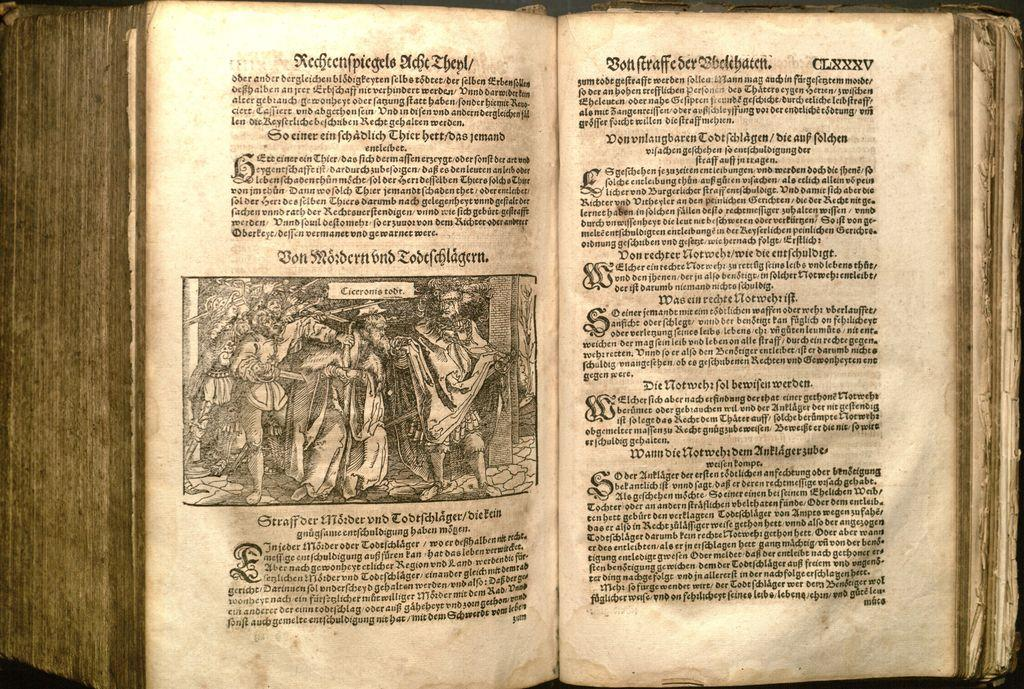<image>
Describe the image concisely. A page of an old book written in a foreign language 